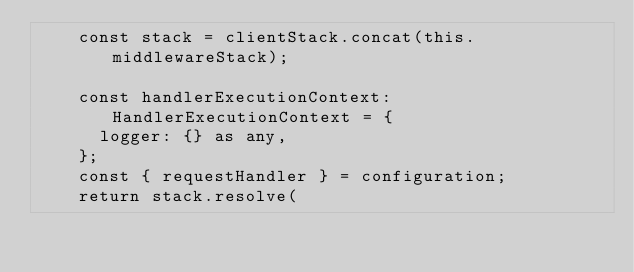<code> <loc_0><loc_0><loc_500><loc_500><_TypeScript_>    const stack = clientStack.concat(this.middlewareStack);

    const handlerExecutionContext: HandlerExecutionContext = {
      logger: {} as any,
    };
    const { requestHandler } = configuration;
    return stack.resolve(</code> 